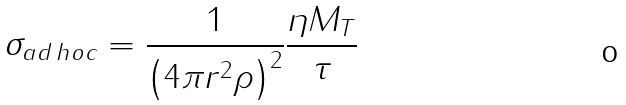Convert formula to latex. <formula><loc_0><loc_0><loc_500><loc_500>\sigma _ { a d \, h o c } = \frac { 1 } { \left ( 4 \pi r ^ { 2 } \rho \right ) ^ { 2 } } \frac { \eta M _ { T } } { \tau }</formula> 